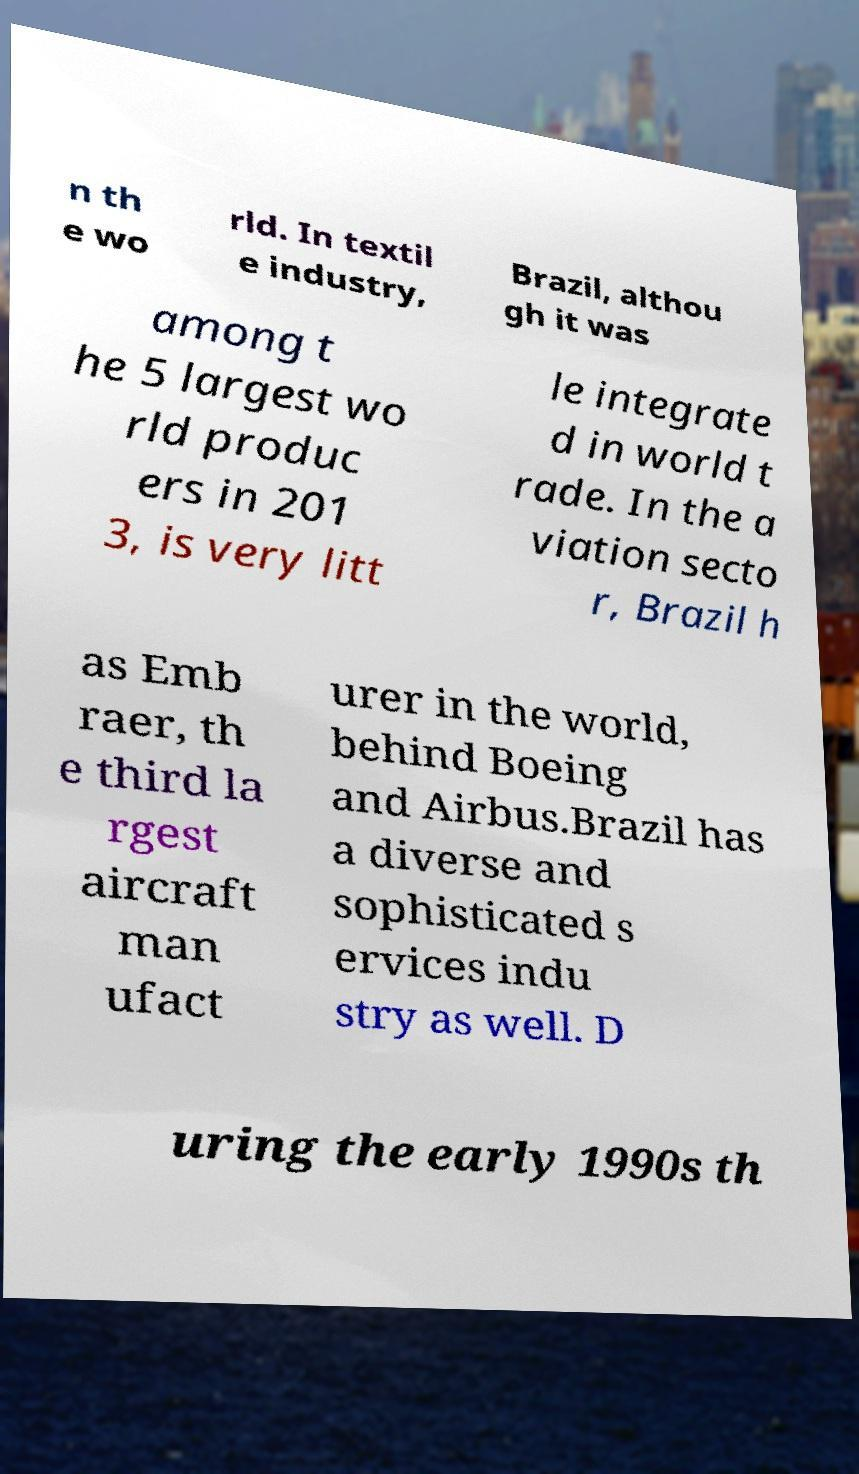Please identify and transcribe the text found in this image. n th e wo rld. In textil e industry, Brazil, althou gh it was among t he 5 largest wo rld produc ers in 201 3, is very litt le integrate d in world t rade. In the a viation secto r, Brazil h as Emb raer, th e third la rgest aircraft man ufact urer in the world, behind Boeing and Airbus.Brazil has a diverse and sophisticated s ervices indu stry as well. D uring the early 1990s th 